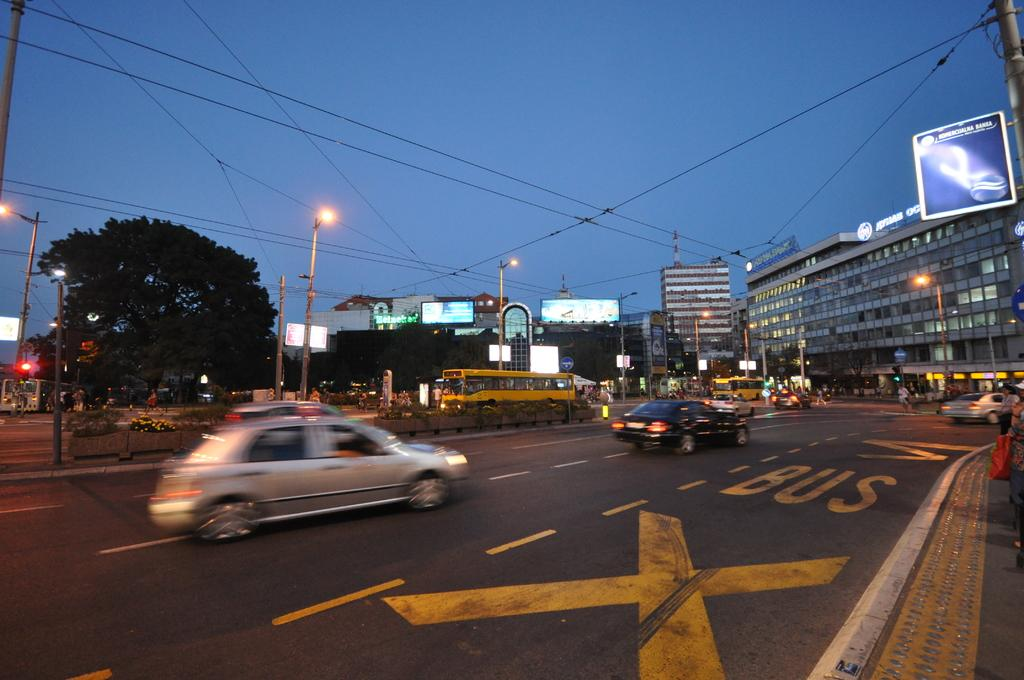Provide a one-sentence caption for the provided image. Cars are driving down a street and the word Bus is painted in yellow on the road. 